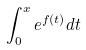Convert formula to latex. <formula><loc_0><loc_0><loc_500><loc_500>\int _ { 0 } ^ { x } e ^ { f ( t ) } d t</formula> 